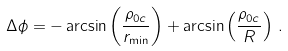<formula> <loc_0><loc_0><loc_500><loc_500>\Delta { \phi } = - \arcsin \left ( \frac { \rho _ { 0 c } } { r _ { \min } } \right ) + \arcsin \left ( \frac { \rho _ { 0 c } } { R } \right ) \, .</formula> 